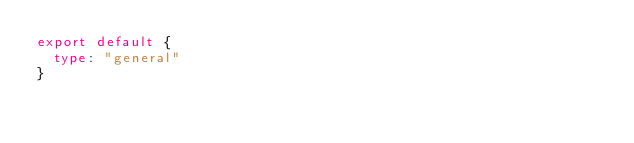Convert code to text. <code><loc_0><loc_0><loc_500><loc_500><_TypeScript_>export default {
	type: "general"   
} </code> 